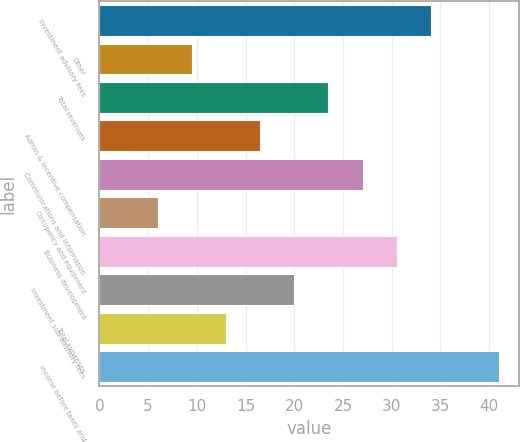<chart> <loc_0><loc_0><loc_500><loc_500><bar_chart><fcel>Investment advisory fees<fcel>Other<fcel>Total revenues<fcel>Admin & incentive compensation<fcel>Communications and information<fcel>Occupancy and equipment<fcel>Business development<fcel>Investment sub-advisory fees<fcel>Total expenses<fcel>Income before taxes and<nl><fcel>34<fcel>9.5<fcel>23.5<fcel>16.5<fcel>27<fcel>6<fcel>30.5<fcel>20<fcel>13<fcel>41<nl></chart> 